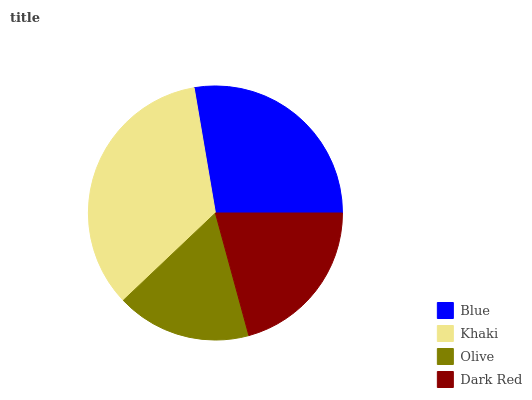Is Olive the minimum?
Answer yes or no. Yes. Is Khaki the maximum?
Answer yes or no. Yes. Is Khaki the minimum?
Answer yes or no. No. Is Olive the maximum?
Answer yes or no. No. Is Khaki greater than Olive?
Answer yes or no. Yes. Is Olive less than Khaki?
Answer yes or no. Yes. Is Olive greater than Khaki?
Answer yes or no. No. Is Khaki less than Olive?
Answer yes or no. No. Is Blue the high median?
Answer yes or no. Yes. Is Dark Red the low median?
Answer yes or no. Yes. Is Khaki the high median?
Answer yes or no. No. Is Khaki the low median?
Answer yes or no. No. 